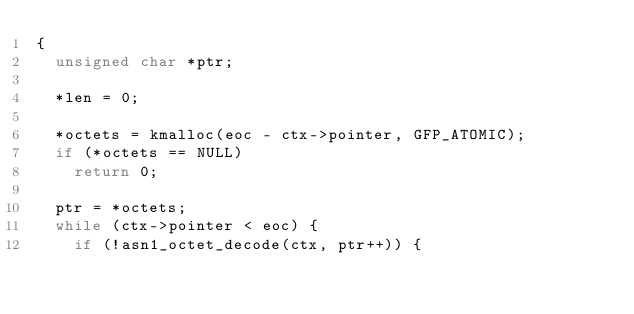<code> <loc_0><loc_0><loc_500><loc_500><_C_>{
	unsigned char *ptr;

	*len = 0;

	*octets = kmalloc(eoc - ctx->pointer, GFP_ATOMIC);
	if (*octets == NULL)
		return 0;

	ptr = *octets;
	while (ctx->pointer < eoc) {
		if (!asn1_octet_decode(ctx, ptr++)) {</code> 